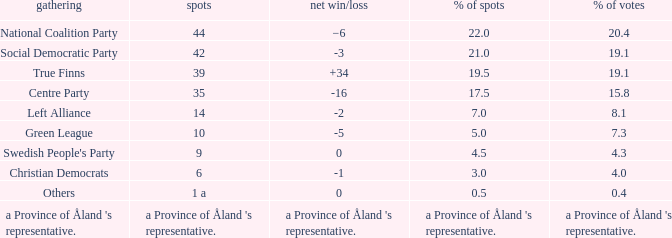Would you be able to parse every entry in this table? {'header': ['gathering', 'spots', 'net win/loss', '% of spots', '% of votes'], 'rows': [['National Coalition Party', '44', '−6', '22.0', '20.4'], ['Social Democratic Party', '42', '-3', '21.0', '19.1'], ['True Finns', '39', '+34', '19.5', '19.1'], ['Centre Party', '35', '-16', '17.5', '15.8'], ['Left Alliance', '14', '-2', '7.0', '8.1'], ['Green League', '10', '-5', '5.0', '7.3'], ["Swedish People's Party", '9', '0', '4.5', '4.3'], ['Christian Democrats', '6', '-1', '3.0', '4.0'], ['Others', '1 a', '0', '0.5', '0.4'], ["a Province of Åland 's representative.", "a Province of Åland 's representative.", "a Province of Åland 's representative.", "a Province of Åland 's representative.", "a Province of Åland 's representative."]]} Which party has a net gain/loss of -2? Left Alliance. 